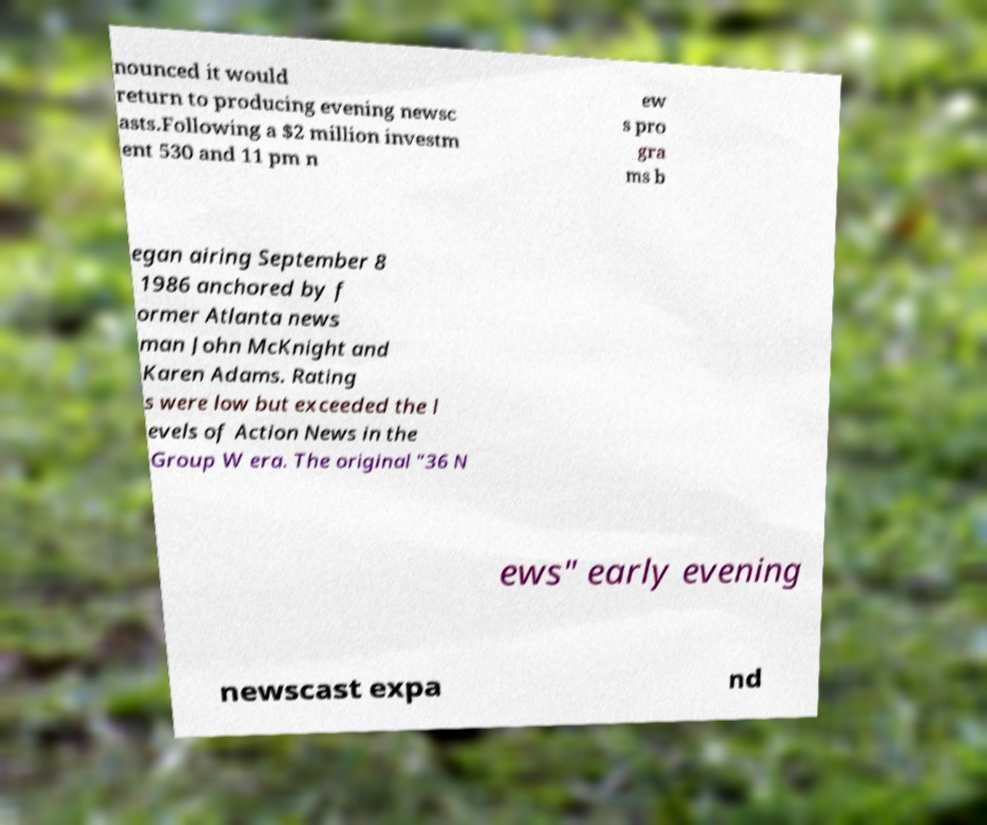Could you extract and type out the text from this image? nounced it would return to producing evening newsc asts.Following a $2 million investm ent 530 and 11 pm n ew s pro gra ms b egan airing September 8 1986 anchored by f ormer Atlanta news man John McKnight and Karen Adams. Rating s were low but exceeded the l evels of Action News in the Group W era. The original "36 N ews" early evening newscast expa nd 